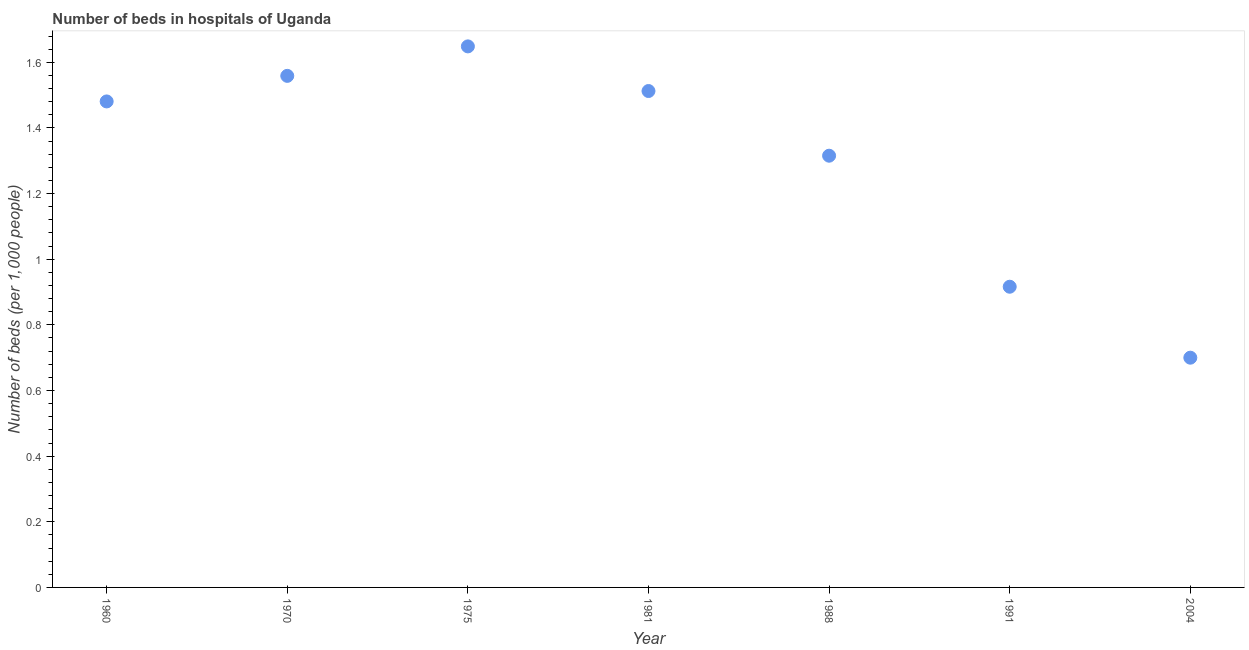What is the number of hospital beds in 1975?
Ensure brevity in your answer.  1.65. Across all years, what is the maximum number of hospital beds?
Your answer should be compact. 1.65. In which year was the number of hospital beds maximum?
Provide a short and direct response. 1975. What is the sum of the number of hospital beds?
Make the answer very short. 9.13. What is the difference between the number of hospital beds in 1981 and 1991?
Your answer should be very brief. 0.6. What is the average number of hospital beds per year?
Offer a terse response. 1.3. What is the median number of hospital beds?
Provide a short and direct response. 1.48. In how many years, is the number of hospital beds greater than 1.52 %?
Your response must be concise. 2. Do a majority of the years between 1988 and 1981 (inclusive) have number of hospital beds greater than 0.4 %?
Give a very brief answer. No. What is the ratio of the number of hospital beds in 1975 to that in 1991?
Provide a short and direct response. 1.8. Is the number of hospital beds in 1960 less than that in 1981?
Ensure brevity in your answer.  Yes. Is the difference between the number of hospital beds in 1970 and 1981 greater than the difference between any two years?
Make the answer very short. No. What is the difference between the highest and the second highest number of hospital beds?
Your answer should be very brief. 0.09. Is the sum of the number of hospital beds in 1970 and 1988 greater than the maximum number of hospital beds across all years?
Make the answer very short. Yes. What is the difference between the highest and the lowest number of hospital beds?
Offer a very short reply. 0.95. How many years are there in the graph?
Your answer should be very brief. 7. What is the difference between two consecutive major ticks on the Y-axis?
Offer a very short reply. 0.2. Are the values on the major ticks of Y-axis written in scientific E-notation?
Provide a succinct answer. No. Does the graph contain any zero values?
Your response must be concise. No. What is the title of the graph?
Offer a terse response. Number of beds in hospitals of Uganda. What is the label or title of the X-axis?
Your answer should be compact. Year. What is the label or title of the Y-axis?
Provide a succinct answer. Number of beds (per 1,0 people). What is the Number of beds (per 1,000 people) in 1960?
Keep it short and to the point. 1.48. What is the Number of beds (per 1,000 people) in 1970?
Provide a short and direct response. 1.56. What is the Number of beds (per 1,000 people) in 1975?
Offer a terse response. 1.65. What is the Number of beds (per 1,000 people) in 1981?
Your answer should be very brief. 1.51. What is the Number of beds (per 1,000 people) in 1988?
Your answer should be compact. 1.32. What is the Number of beds (per 1,000 people) in 1991?
Ensure brevity in your answer.  0.92. What is the difference between the Number of beds (per 1,000 people) in 1960 and 1970?
Keep it short and to the point. -0.08. What is the difference between the Number of beds (per 1,000 people) in 1960 and 1975?
Offer a terse response. -0.17. What is the difference between the Number of beds (per 1,000 people) in 1960 and 1981?
Give a very brief answer. -0.03. What is the difference between the Number of beds (per 1,000 people) in 1960 and 1988?
Ensure brevity in your answer.  0.17. What is the difference between the Number of beds (per 1,000 people) in 1960 and 1991?
Your answer should be very brief. 0.56. What is the difference between the Number of beds (per 1,000 people) in 1960 and 2004?
Your answer should be very brief. 0.78. What is the difference between the Number of beds (per 1,000 people) in 1970 and 1975?
Provide a succinct answer. -0.09. What is the difference between the Number of beds (per 1,000 people) in 1970 and 1981?
Keep it short and to the point. 0.05. What is the difference between the Number of beds (per 1,000 people) in 1970 and 1988?
Provide a succinct answer. 0.24. What is the difference between the Number of beds (per 1,000 people) in 1970 and 1991?
Ensure brevity in your answer.  0.64. What is the difference between the Number of beds (per 1,000 people) in 1970 and 2004?
Your answer should be very brief. 0.86. What is the difference between the Number of beds (per 1,000 people) in 1975 and 1981?
Offer a very short reply. 0.14. What is the difference between the Number of beds (per 1,000 people) in 1975 and 1988?
Make the answer very short. 0.33. What is the difference between the Number of beds (per 1,000 people) in 1975 and 1991?
Ensure brevity in your answer.  0.73. What is the difference between the Number of beds (per 1,000 people) in 1975 and 2004?
Ensure brevity in your answer.  0.95. What is the difference between the Number of beds (per 1,000 people) in 1981 and 1988?
Offer a very short reply. 0.2. What is the difference between the Number of beds (per 1,000 people) in 1981 and 1991?
Your answer should be compact. 0.6. What is the difference between the Number of beds (per 1,000 people) in 1981 and 2004?
Your answer should be very brief. 0.81. What is the difference between the Number of beds (per 1,000 people) in 1988 and 1991?
Offer a very short reply. 0.4. What is the difference between the Number of beds (per 1,000 people) in 1988 and 2004?
Give a very brief answer. 0.62. What is the difference between the Number of beds (per 1,000 people) in 1991 and 2004?
Ensure brevity in your answer.  0.22. What is the ratio of the Number of beds (per 1,000 people) in 1960 to that in 1975?
Keep it short and to the point. 0.9. What is the ratio of the Number of beds (per 1,000 people) in 1960 to that in 1981?
Provide a succinct answer. 0.98. What is the ratio of the Number of beds (per 1,000 people) in 1960 to that in 1988?
Your answer should be compact. 1.13. What is the ratio of the Number of beds (per 1,000 people) in 1960 to that in 1991?
Offer a terse response. 1.62. What is the ratio of the Number of beds (per 1,000 people) in 1960 to that in 2004?
Make the answer very short. 2.12. What is the ratio of the Number of beds (per 1,000 people) in 1970 to that in 1975?
Offer a terse response. 0.95. What is the ratio of the Number of beds (per 1,000 people) in 1970 to that in 1981?
Offer a terse response. 1.03. What is the ratio of the Number of beds (per 1,000 people) in 1970 to that in 1988?
Your answer should be very brief. 1.19. What is the ratio of the Number of beds (per 1,000 people) in 1970 to that in 1991?
Make the answer very short. 1.7. What is the ratio of the Number of beds (per 1,000 people) in 1970 to that in 2004?
Give a very brief answer. 2.23. What is the ratio of the Number of beds (per 1,000 people) in 1975 to that in 1981?
Your answer should be compact. 1.09. What is the ratio of the Number of beds (per 1,000 people) in 1975 to that in 1988?
Your answer should be very brief. 1.25. What is the ratio of the Number of beds (per 1,000 people) in 1975 to that in 1991?
Ensure brevity in your answer.  1.8. What is the ratio of the Number of beds (per 1,000 people) in 1975 to that in 2004?
Your answer should be compact. 2.35. What is the ratio of the Number of beds (per 1,000 people) in 1981 to that in 1988?
Provide a short and direct response. 1.15. What is the ratio of the Number of beds (per 1,000 people) in 1981 to that in 1991?
Make the answer very short. 1.65. What is the ratio of the Number of beds (per 1,000 people) in 1981 to that in 2004?
Your answer should be very brief. 2.16. What is the ratio of the Number of beds (per 1,000 people) in 1988 to that in 1991?
Provide a short and direct response. 1.44. What is the ratio of the Number of beds (per 1,000 people) in 1988 to that in 2004?
Provide a short and direct response. 1.88. What is the ratio of the Number of beds (per 1,000 people) in 1991 to that in 2004?
Make the answer very short. 1.31. 